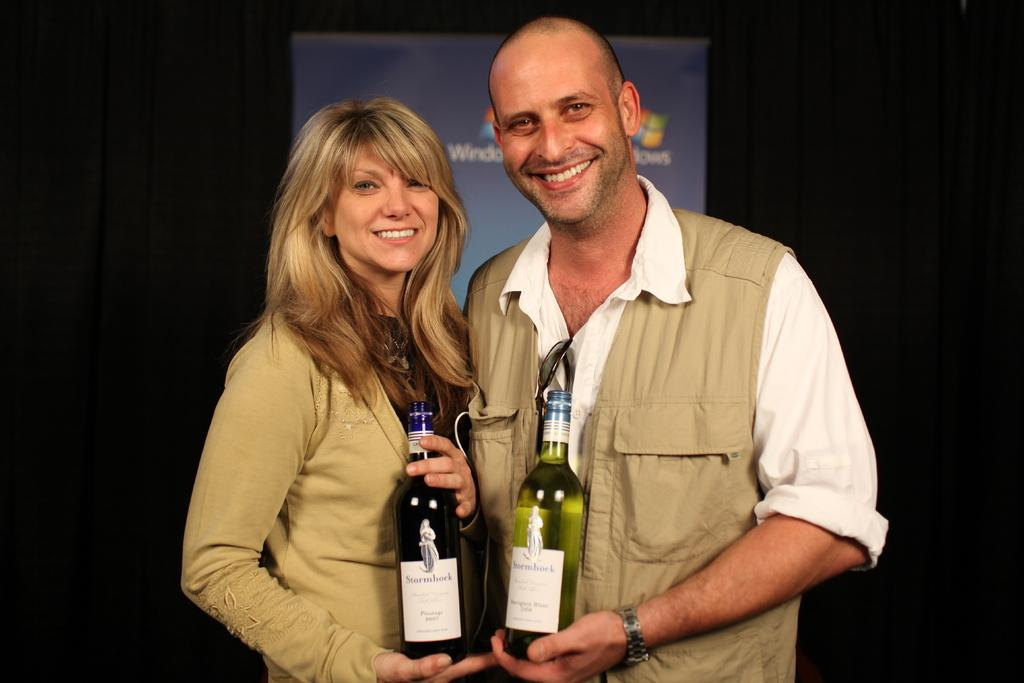How many people are in the image? There are three people in the image: two women and a man. What are the people in the image doing? They are standing and smiling. What are the people holding in the image? They are holding bottles. What can be seen on the bottles? There is a sticker on the bottles. What is visible on the back side of the image? There is a screen visible on the back side of the image. What type of oatmeal is being prepared in the image? There is no oatmeal present in the image. What is the income of the man in the image? The income of the man in the image cannot be determined from the image. 